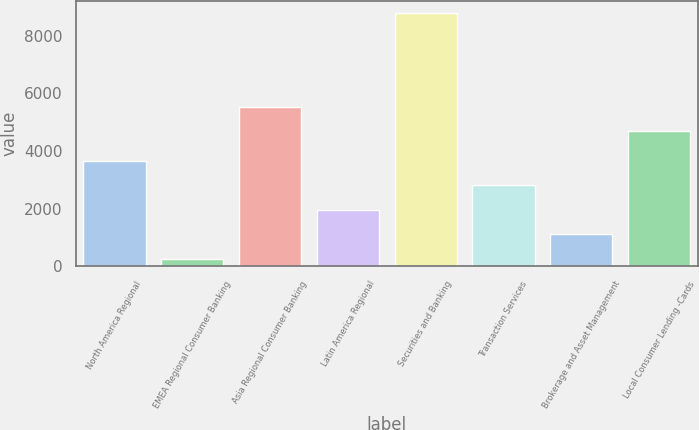<chart> <loc_0><loc_0><loc_500><loc_500><bar_chart><fcel>North America Regional<fcel>EMEA Regional Consumer Banking<fcel>Asia Regional Consumer Banking<fcel>Latin America Regional<fcel>Securities and Banking<fcel>Transaction Services<fcel>Brokerage and Asset Management<fcel>Local Consumer Lending -Cards<nl><fcel>3666.6<fcel>255<fcel>5535.9<fcel>1960.8<fcel>8784<fcel>2813.7<fcel>1107.9<fcel>4683<nl></chart> 